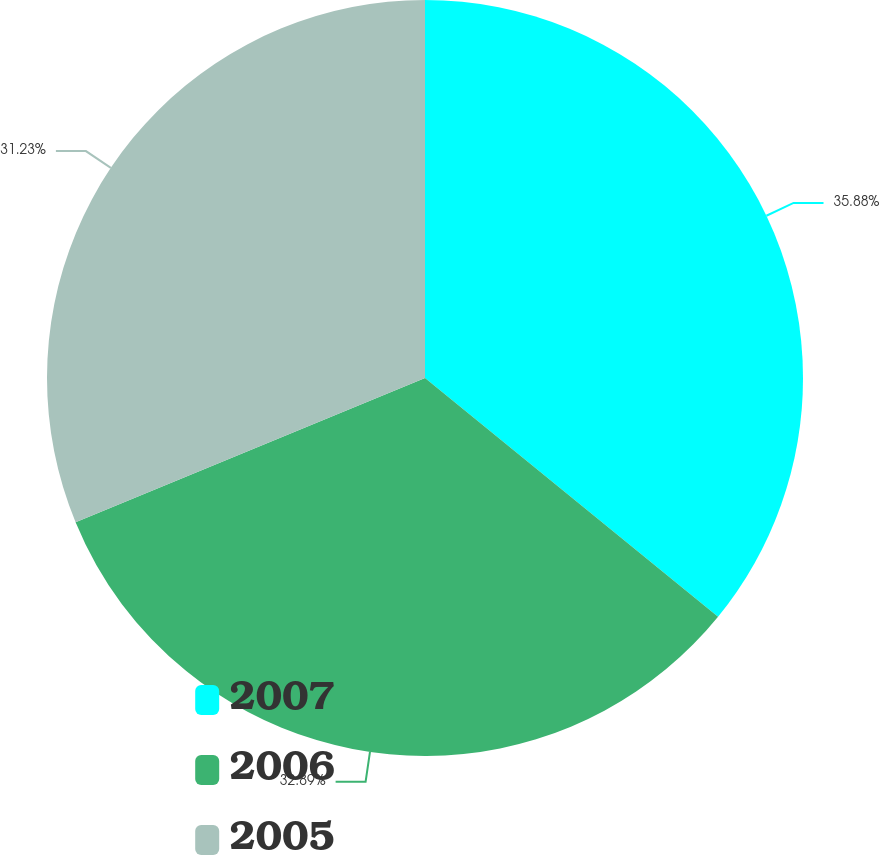Convert chart to OTSL. <chart><loc_0><loc_0><loc_500><loc_500><pie_chart><fcel>2007<fcel>2006<fcel>2005<nl><fcel>35.88%<fcel>32.89%<fcel>31.23%<nl></chart> 